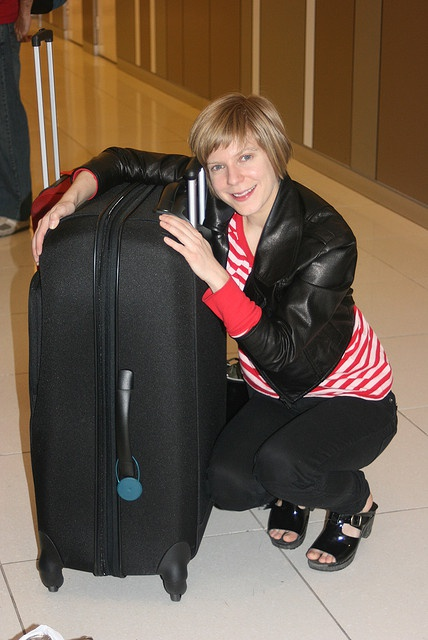Describe the objects in this image and their specific colors. I can see people in maroon, black, tan, lightgray, and gray tones, suitcase in maroon, black, gray, darkgray, and tan tones, and people in maroon, black, and brown tones in this image. 